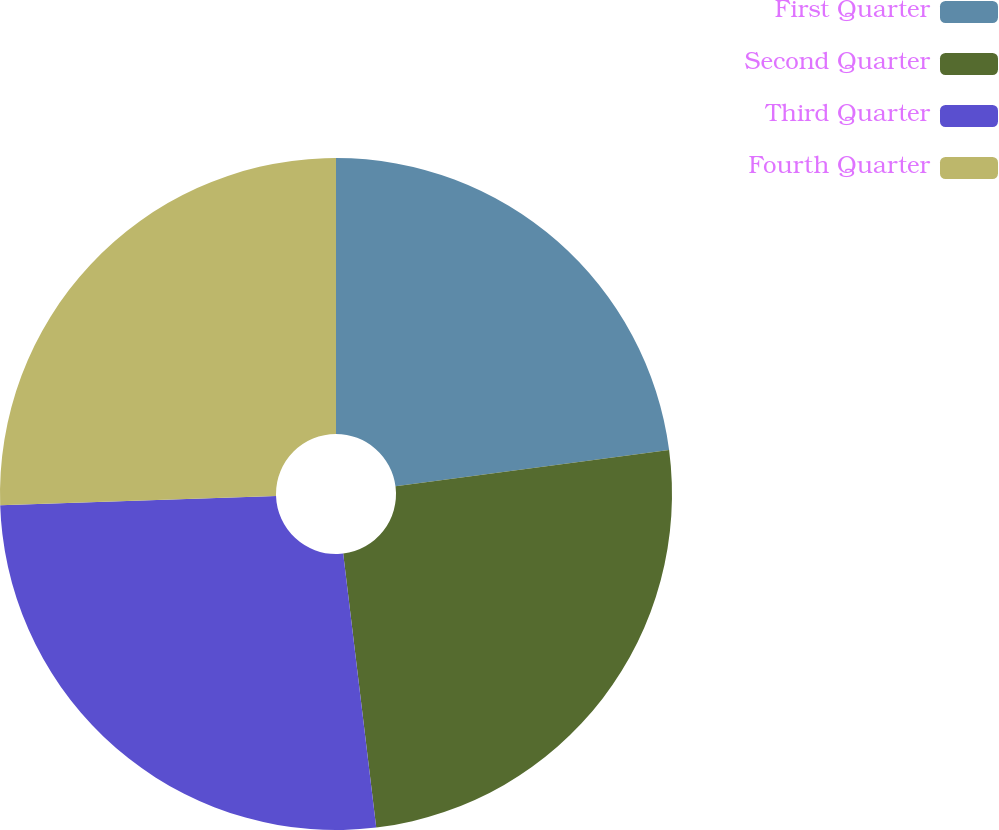<chart> <loc_0><loc_0><loc_500><loc_500><pie_chart><fcel>First Quarter<fcel>Second Quarter<fcel>Third Quarter<fcel>Fourth Quarter<nl><fcel>22.91%<fcel>25.18%<fcel>26.38%<fcel>25.53%<nl></chart> 